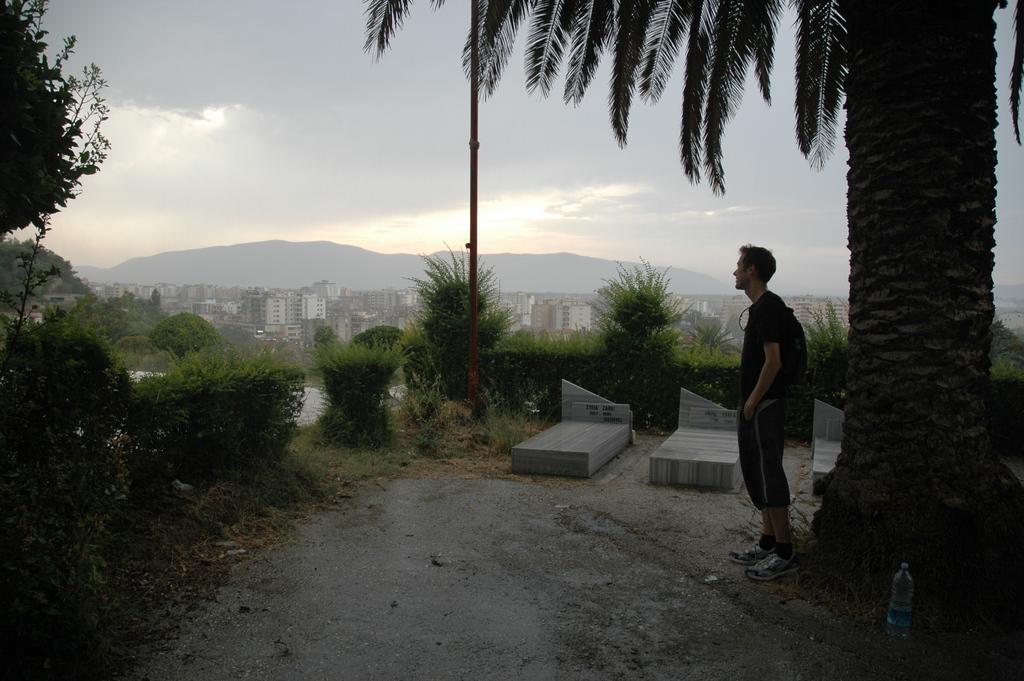How would you summarize this image in a sentence or two? In this image I can see a man under a tree. Here I can see number of plants, number of buildings. I can also see a mountain. 